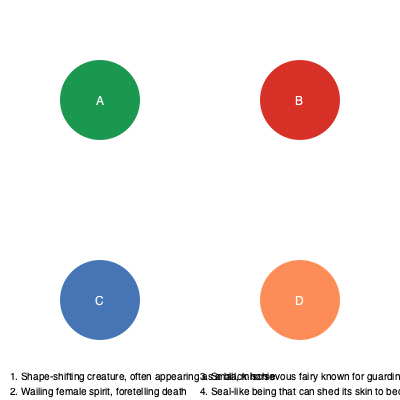Match the Irish mythological creatures (A, B, C, D) to their correct descriptions (1, 2, 3, 4). To match the Irish mythological creatures to their descriptions, let's go through each one:

1. A - This green circle likely represents a Leprechaun, which matches description 3: "Small, mischievous fairy known for guarding treasure." Leprechauns are famous in Irish folklore for their pot of gold at the end of the rainbow.

2. B - The red circle likely symbolizes a Banshee, corresponding to description 2: "Wailing female spirit, foretelling death." In Irish mythology, the cry of a Banshee is said to predict an upcoming death in the family.

3. C - The blue circle probably represents a Selkie, matching description 4: "Seal-like being that can shed its skin to become human." Selkies are mythical creatures from Irish and Scottish folklore that can transform from seals to humans by shedding their skin.

4. D - The orange circle likely depicts a Púca, which fits description 1: "Shape-shifting creature, often appearing as a black horse." Púcas are shape-shifters in Irish folklore, known for their ability to take various animal forms, with a black horse being one of the most common.

Therefore, the correct matching is:
A - 3
B - 2
C - 4
D - 1
Answer: A3, B2, C4, D1 